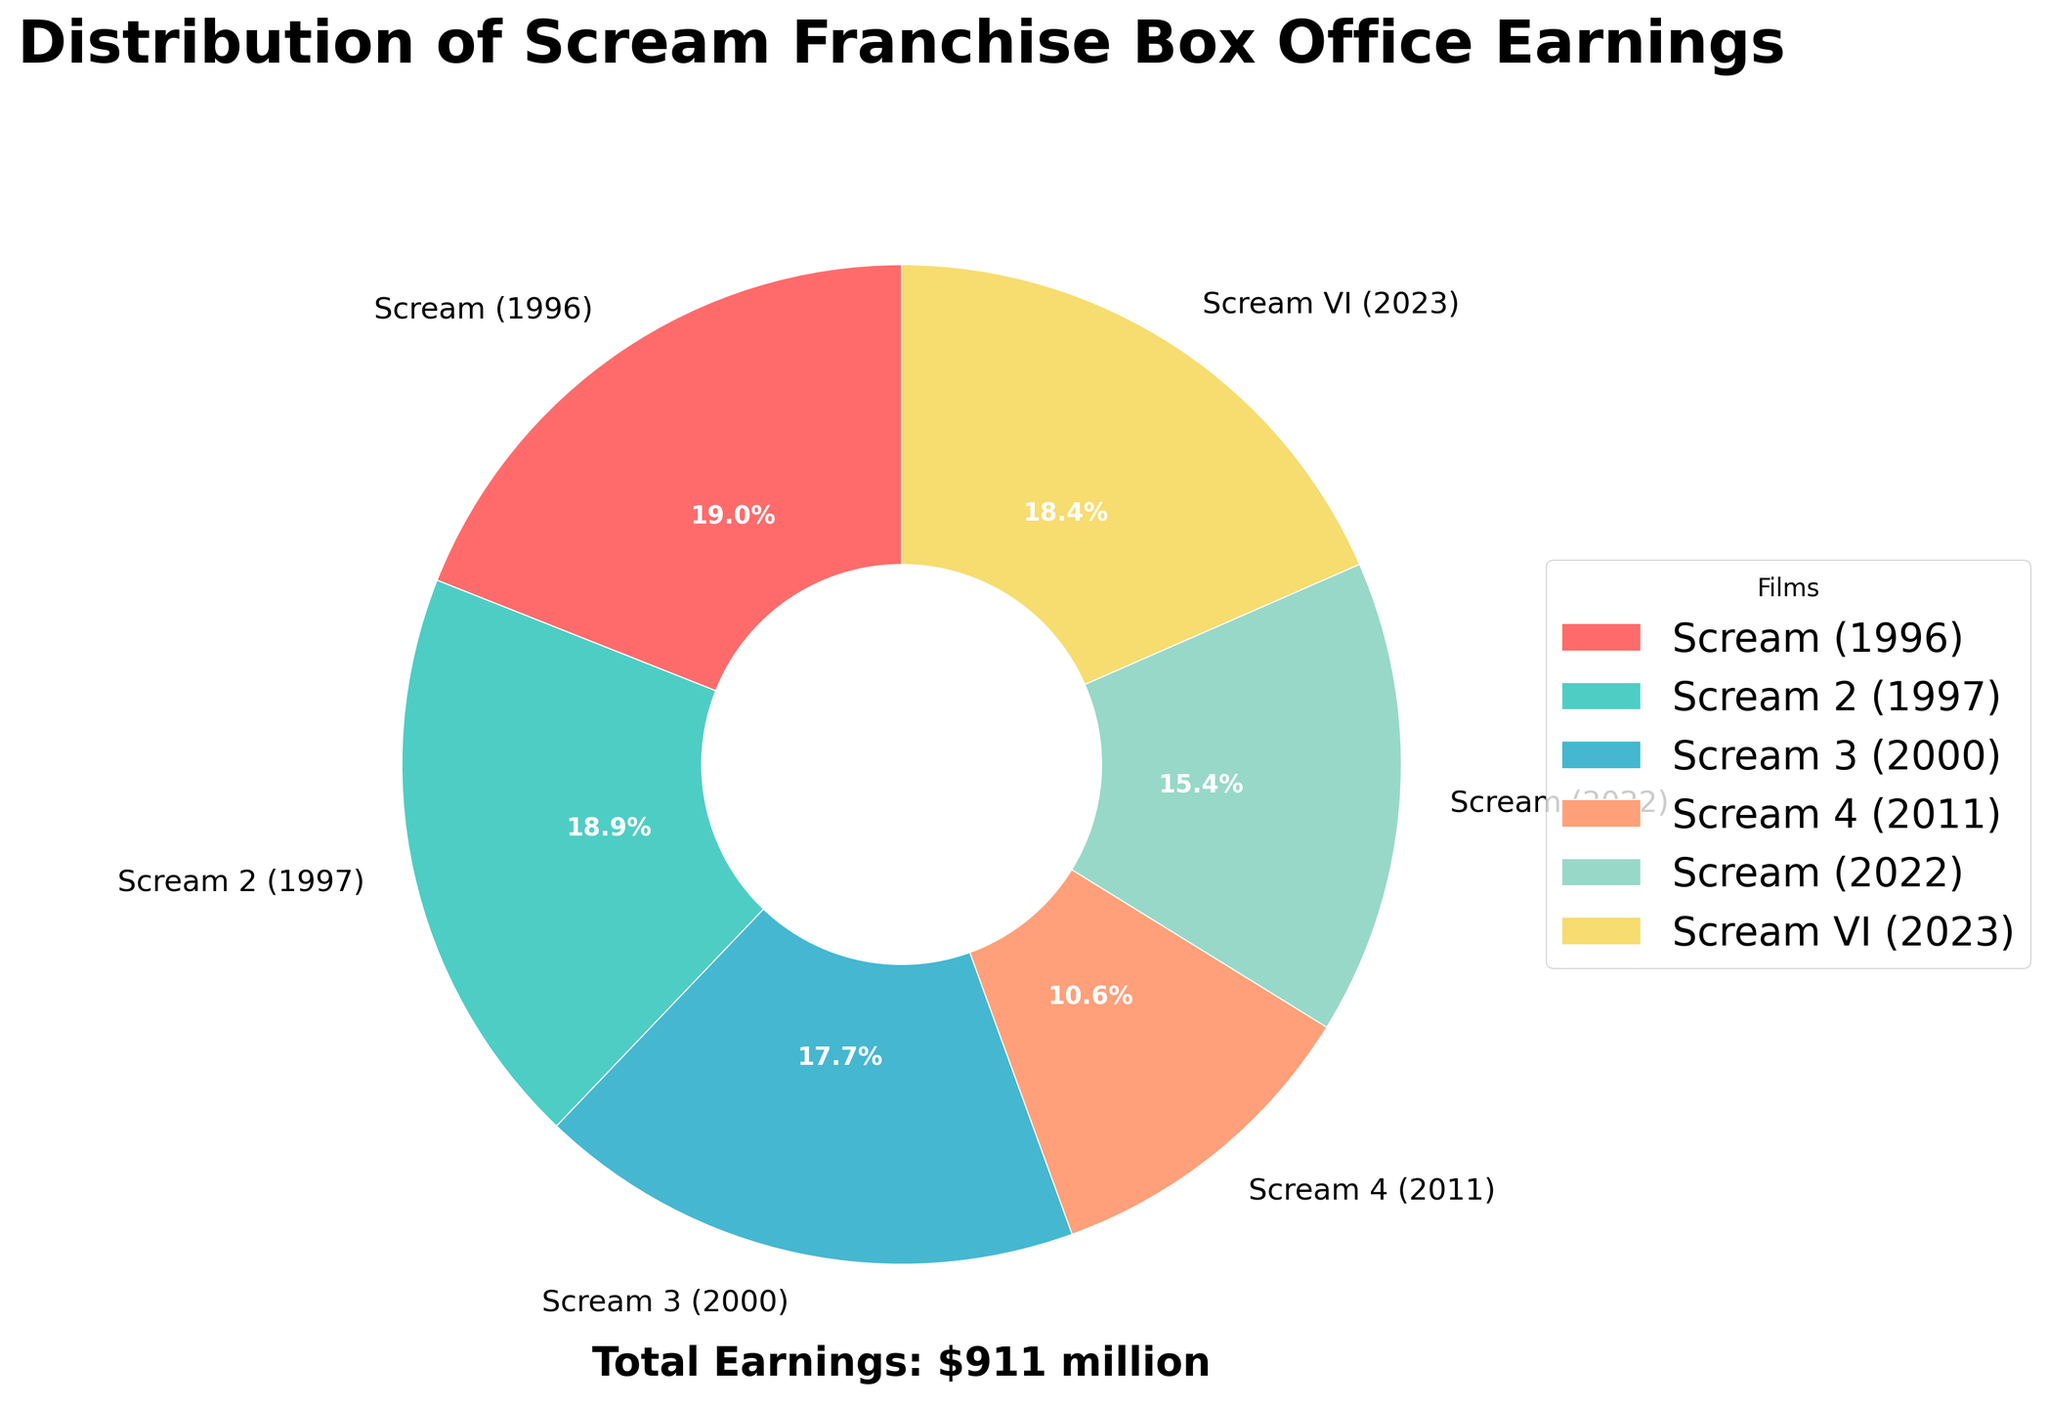What percentage of the total box office earnings is attributed to Scream (1996)? From the pie chart, check the portion labeled "Scream (1996)." The percentage value for this segment is explicitly mentioned.
Answer: 25.1% Which film contributed the least to the box office earnings? Observe the smallest slice in the pie chart, which represents the film with the lowest earnings. The label next to this slice indicates the film's name.
Answer: Scream 4 (2011) How does the box office earning of Scream VI (2023) compare to Scream (2022)? Identify the slices for "Scream VI (2023)" and "Scream (2022)" in the pie chart. Compare their sizes and the percentage values labeled on each slice.
Answer: Scream VI (2023) earned more What is the combined box office earnings of Scream (1996) and Scream 2 (1997) as a percentage of the total? Find the percentage values for "Scream (1996)" and "Scream 2 (1997)" from the pie chart. Sum these percentages to get the combined earnings. 25.1% (Scream 1996) + 25.0% (Scream 2) = 50.1%
Answer: 50.1% Which film has the second highest box office earnings? Locate the largest slice first, then find the second largest slice in the pie chart to determine the film associated with it.
Answer: Scream VI (2023) How do the earnings of the first two films (Scream and Scream 2) combined compare to the entire series? The pie chart indicates the percentage values for "Scream (1996)" and "Scream 2 (1997)." Add these percentages: 25.1% + 25.0% = 50.1%. Compare this sum to the whole pie chart (100%).
Answer: They make up 50.1% of the entire series Identify the film represented by the segment colored blue. Check the legend that matches film names with their corresponding colors in the pie chart. Locate the blue color and read the associated film name.
Answer: Scream VI (2023) What is the approximate difference in box office earnings between Scream 3 (2000) and Scream 4 (2011)? Note the percentage values for "Scream 3 (2000)" and "Scream 4 (2011)" from the pie chart. Calculate the difference between these values: 23.3% - 14.0% = 9.3%. Convert this back to actual earnings if needed: $161 million (Scream 3) - $97 million (Scream 4) = $64 million.
Answer: $64 million Which films together account for almost half of the total box office earnings? Look at the segments labeled "Scream (1996)" and "Scream 2 (1997)." Sum their percentages: 25.1% + 25.0% = 50.1%. These two films together account for nearly half of the total earnings.
Answer: Scream (1996) and Scream 2 (1997) What is the total box office earnings of the Scream franchise? Locate the total earnings text in the pie chart that usually specifies this information.
Answer: $911 million 